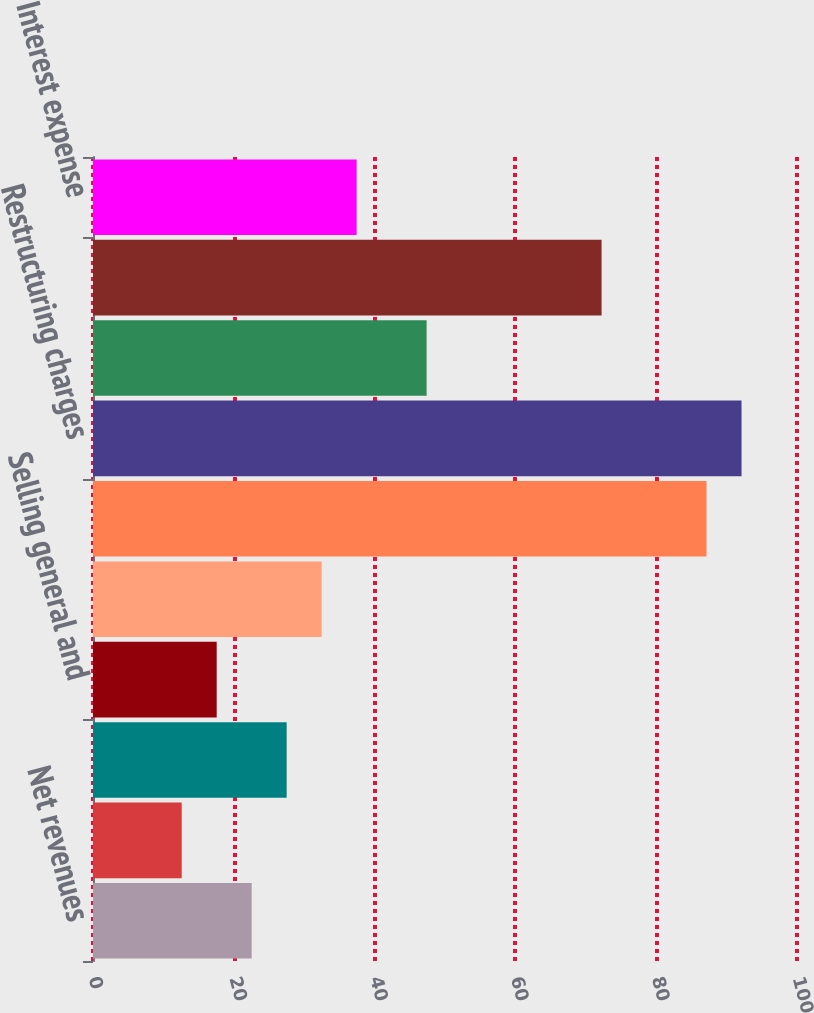Convert chart to OTSL. <chart><loc_0><loc_0><loc_500><loc_500><bar_chart><fcel>Net revenues<fcel>Cost of goods sold (a)<fcel>Gross profit<fcel>Selling general and<fcel>Amortization of intangible<fcel>Impairments of assets<fcel>Restructuring charges<fcel>Operating income<fcel>Foreign currency gains<fcel>Interest expense<nl><fcel>22.54<fcel>12.6<fcel>27.51<fcel>17.57<fcel>32.48<fcel>87.15<fcel>92.12<fcel>47.39<fcel>72.24<fcel>37.45<nl></chart> 